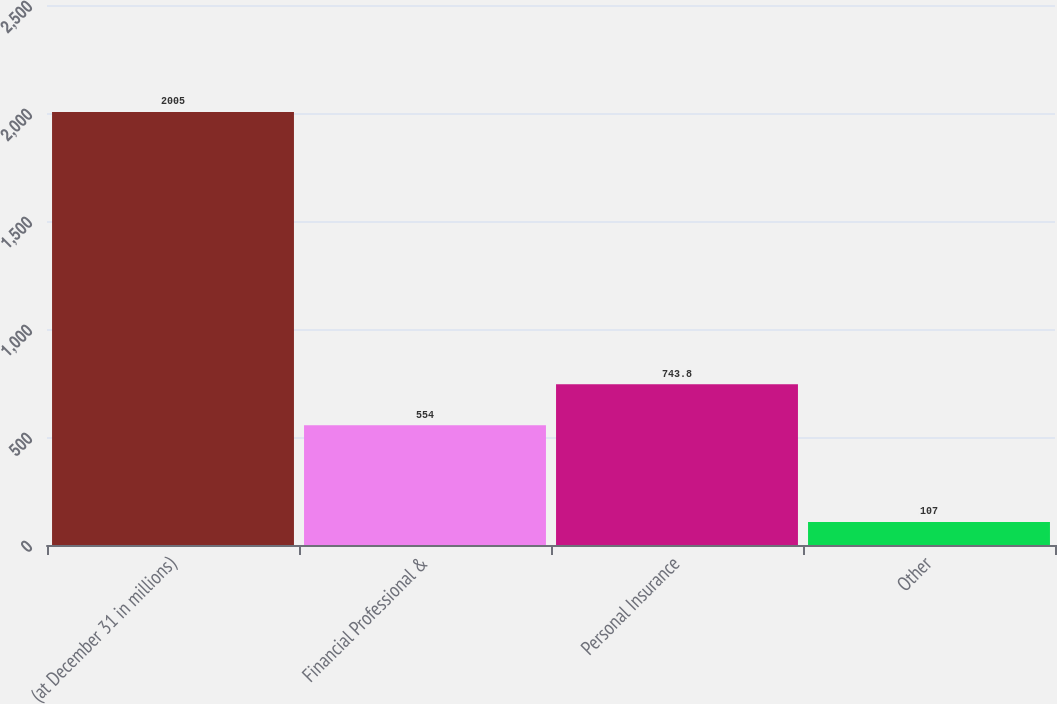Convert chart to OTSL. <chart><loc_0><loc_0><loc_500><loc_500><bar_chart><fcel>(at December 31 in millions)<fcel>Financial Professional &<fcel>Personal Insurance<fcel>Other<nl><fcel>2005<fcel>554<fcel>743.8<fcel>107<nl></chart> 